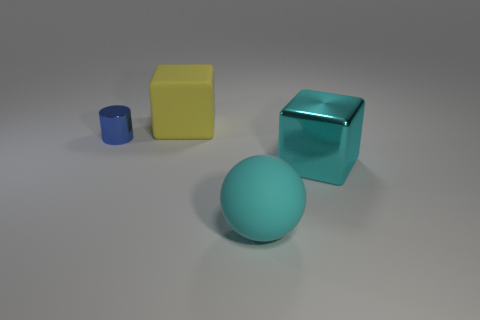Add 3 tiny blue objects. How many objects exist? 7 Subtract all cylinders. How many objects are left? 3 Subtract all yellow cubes. How many cubes are left? 1 Subtract all cyan blocks. Subtract all brown spheres. How many blocks are left? 1 Subtract all big blue metal cylinders. Subtract all large blocks. How many objects are left? 2 Add 1 cyan rubber spheres. How many cyan rubber spheres are left? 2 Add 1 gray cylinders. How many gray cylinders exist? 1 Subtract 0 red spheres. How many objects are left? 4 